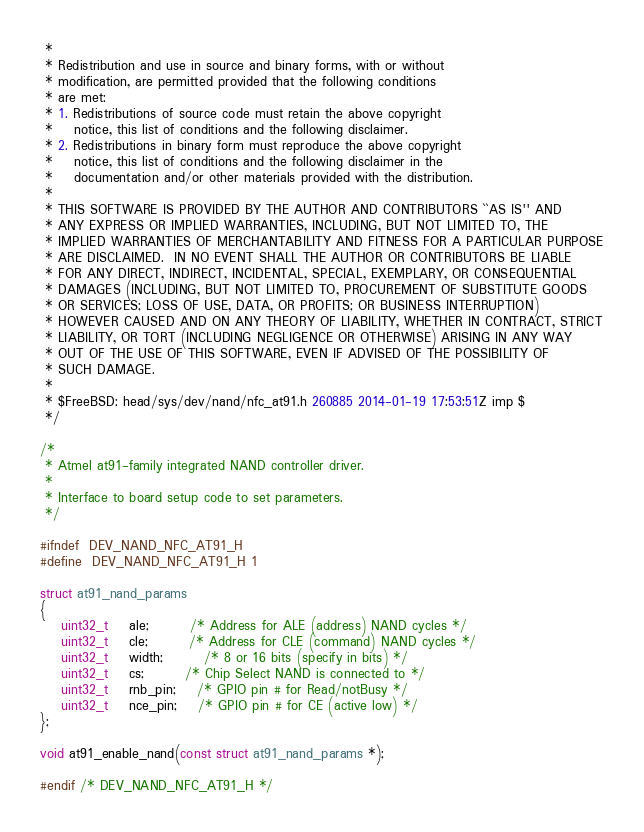<code> <loc_0><loc_0><loc_500><loc_500><_C_> *
 * Redistribution and use in source and binary forms, with or without
 * modification, are permitted provided that the following conditions
 * are met:
 * 1. Redistributions of source code must retain the above copyright
 *    notice, this list of conditions and the following disclaimer.
 * 2. Redistributions in binary form must reproduce the above copyright
 *    notice, this list of conditions and the following disclaimer in the
 *    documentation and/or other materials provided with the distribution.
 *
 * THIS SOFTWARE IS PROVIDED BY THE AUTHOR AND CONTRIBUTORS ``AS IS'' AND
 * ANY EXPRESS OR IMPLIED WARRANTIES, INCLUDING, BUT NOT LIMITED TO, THE
 * IMPLIED WARRANTIES OF MERCHANTABILITY AND FITNESS FOR A PARTICULAR PURPOSE
 * ARE DISCLAIMED.  IN NO EVENT SHALL THE AUTHOR OR CONTRIBUTORS BE LIABLE
 * FOR ANY DIRECT, INDIRECT, INCIDENTAL, SPECIAL, EXEMPLARY, OR CONSEQUENTIAL
 * DAMAGES (INCLUDING, BUT NOT LIMITED TO, PROCUREMENT OF SUBSTITUTE GOODS
 * OR SERVICES; LOSS OF USE, DATA, OR PROFITS; OR BUSINESS INTERRUPTION)
 * HOWEVER CAUSED AND ON ANY THEORY OF LIABILITY, WHETHER IN CONTRACT, STRICT
 * LIABILITY, OR TORT (INCLUDING NEGLIGENCE OR OTHERWISE) ARISING IN ANY WAY
 * OUT OF THE USE OF THIS SOFTWARE, EVEN IF ADVISED OF THE POSSIBILITY OF
 * SUCH DAMAGE.
 *
 * $FreeBSD: head/sys/dev/nand/nfc_at91.h 260885 2014-01-19 17:53:51Z imp $
 */

/*
 * Atmel at91-family integrated NAND controller driver.
 *
 * Interface to board setup code to set parameters.
 */

#ifndef	DEV_NAND_NFC_AT91_H
#define	DEV_NAND_NFC_AT91_H 1

struct at91_nand_params 
{
	uint32_t	ale;		/* Address for ALE (address) NAND cycles */
	uint32_t	cle;		/* Address for CLE (command) NAND cycles */
	uint32_t	width;		/* 8 or 16 bits (specify in bits) */
	uint32_t	cs;		/* Chip Select NAND is connected to */
	uint32_t	rnb_pin;	/* GPIO pin # for Read/notBusy */
	uint32_t	nce_pin;	/* GPIO pin # for CE (active low) */
};

void at91_enable_nand(const struct at91_nand_params *);

#endif /* DEV_NAND_NFC_AT91_H */
</code> 